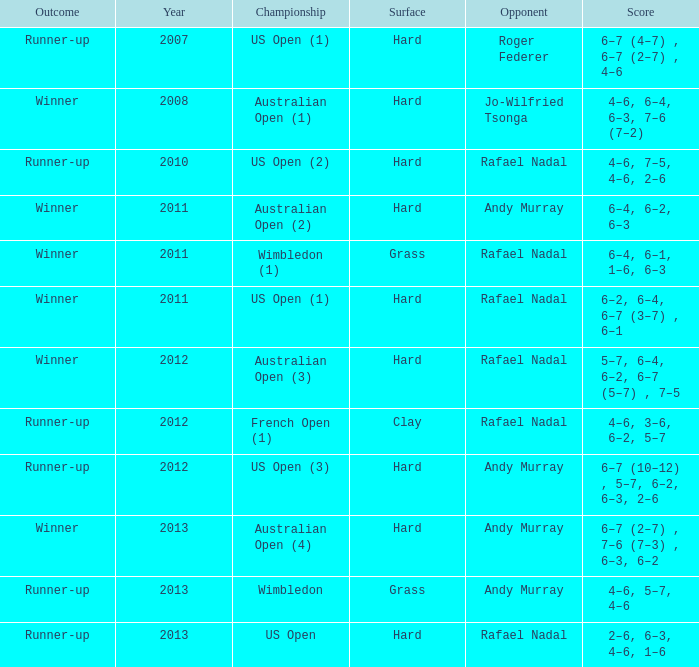What is the outcome of the 4–6, 6–4, 6–3, 7–6 (7–2) score? Winner. 